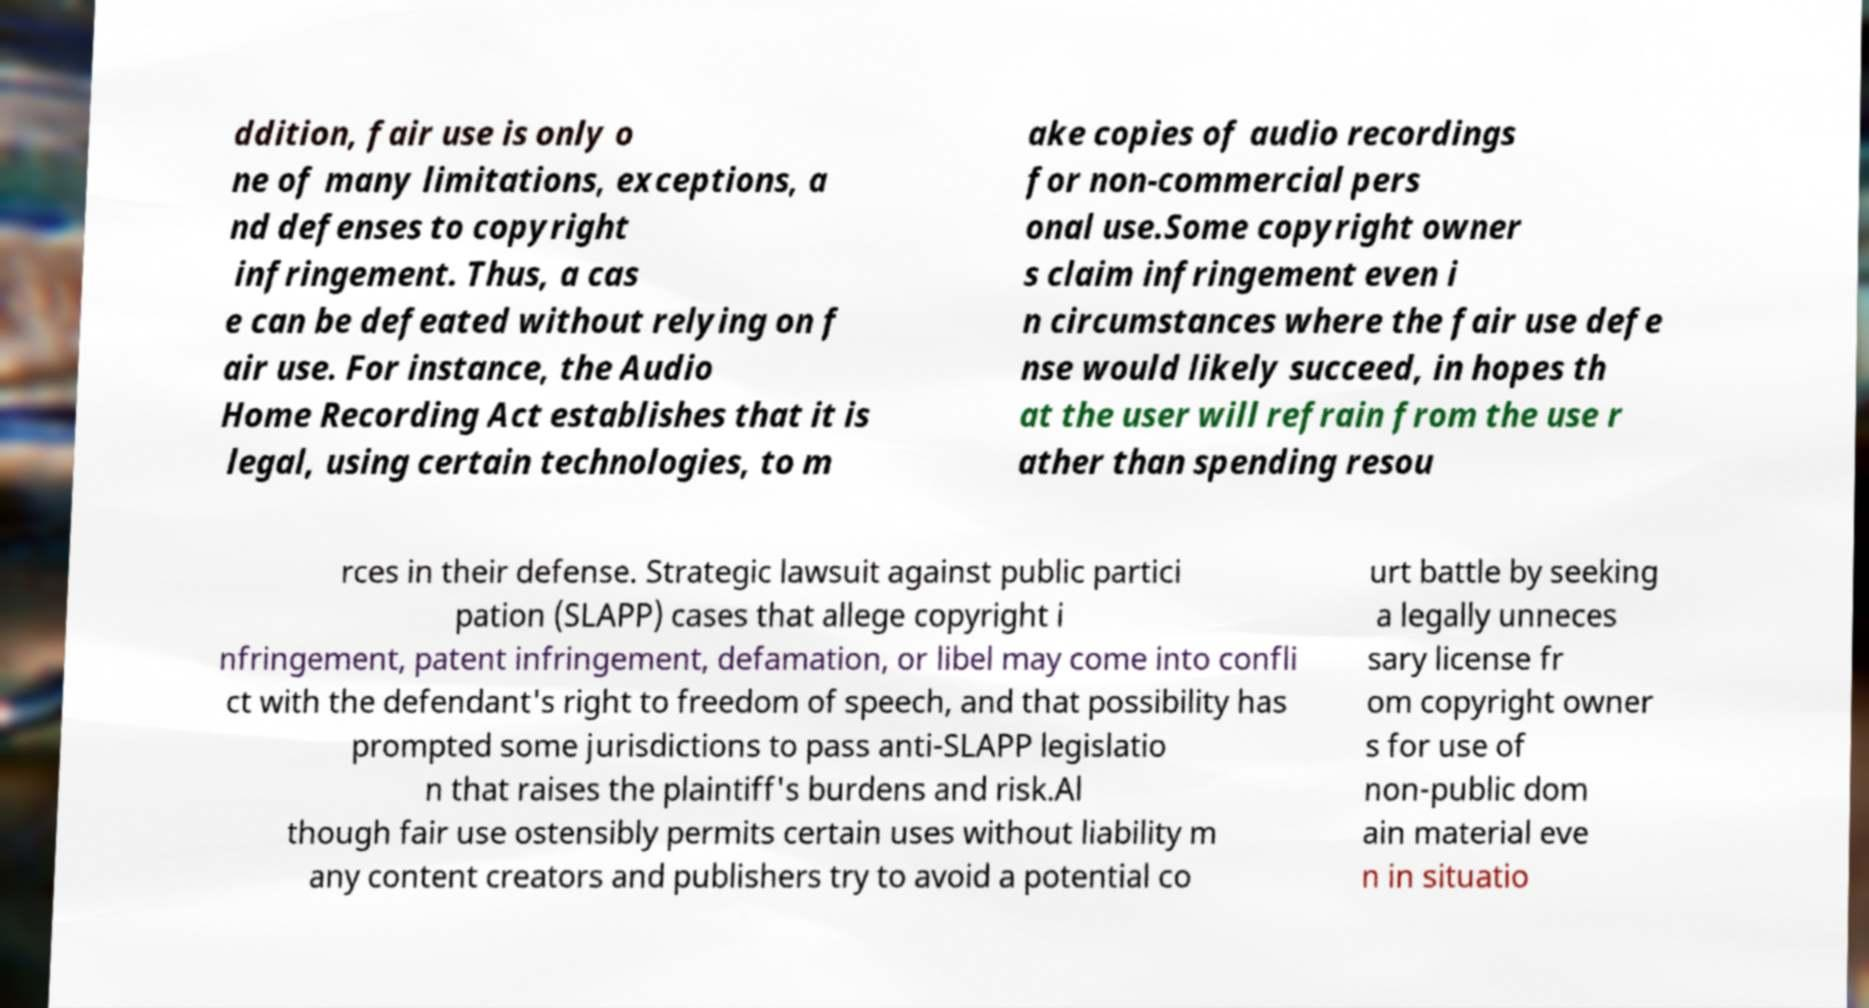Can you read and provide the text displayed in the image?This photo seems to have some interesting text. Can you extract and type it out for me? ddition, fair use is only o ne of many limitations, exceptions, a nd defenses to copyright infringement. Thus, a cas e can be defeated without relying on f air use. For instance, the Audio Home Recording Act establishes that it is legal, using certain technologies, to m ake copies of audio recordings for non-commercial pers onal use.Some copyright owner s claim infringement even i n circumstances where the fair use defe nse would likely succeed, in hopes th at the user will refrain from the use r ather than spending resou rces in their defense. Strategic lawsuit against public partici pation (SLAPP) cases that allege copyright i nfringement, patent infringement, defamation, or libel may come into confli ct with the defendant's right to freedom of speech, and that possibility has prompted some jurisdictions to pass anti-SLAPP legislatio n that raises the plaintiff's burdens and risk.Al though fair use ostensibly permits certain uses without liability m any content creators and publishers try to avoid a potential co urt battle by seeking a legally unneces sary license fr om copyright owner s for use of non-public dom ain material eve n in situatio 